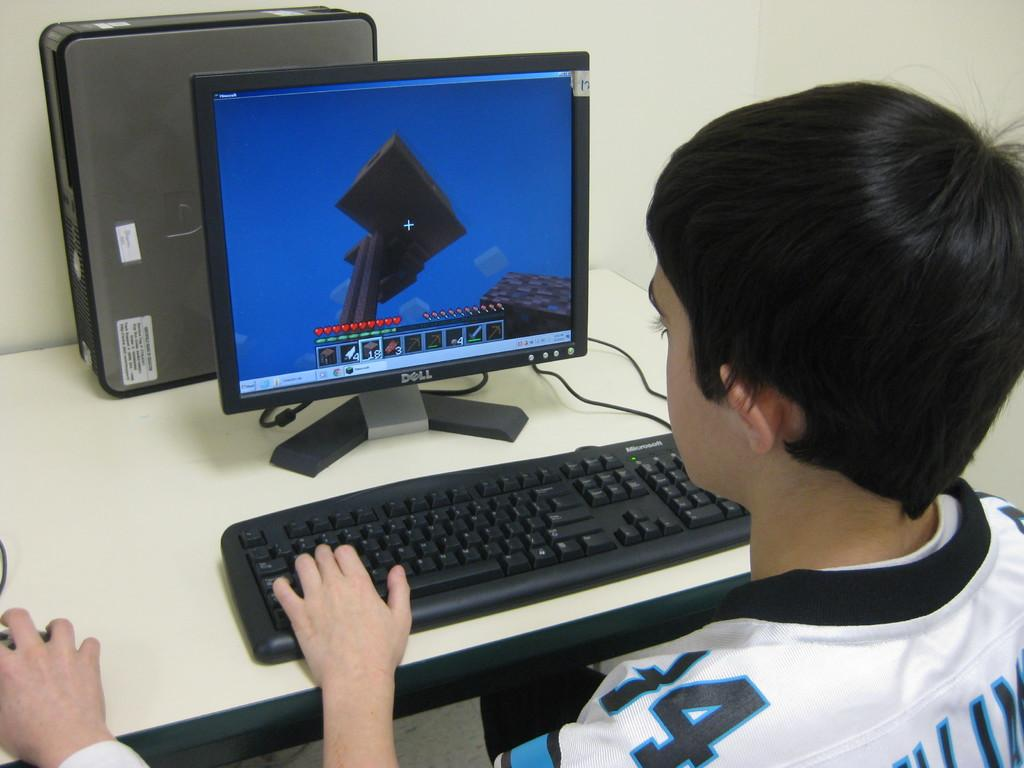<image>
Create a compact narrative representing the image presented. A young boy works on a computer in front of a Dell brand monitor. 